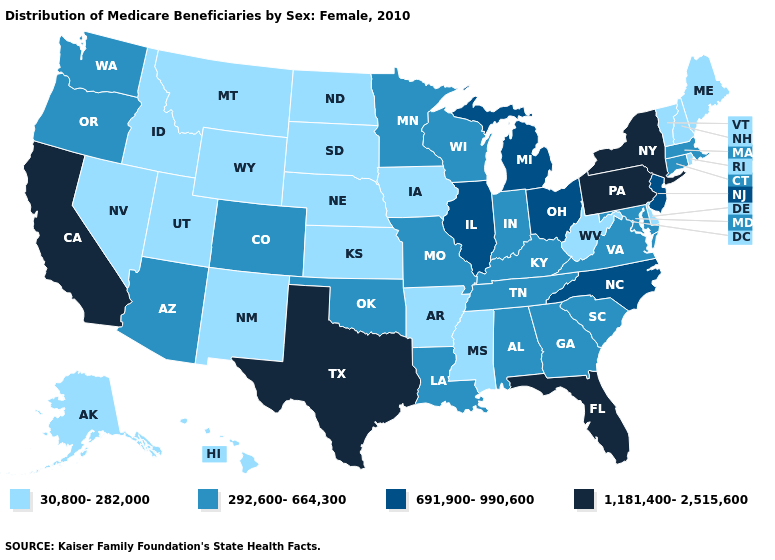Does the first symbol in the legend represent the smallest category?
Short answer required. Yes. Which states hav the highest value in the Northeast?
Answer briefly. New York, Pennsylvania. Among the states that border South Dakota , does Minnesota have the highest value?
Quick response, please. Yes. Does New Hampshire have the lowest value in the Northeast?
Answer briefly. Yes. What is the lowest value in the USA?
Short answer required. 30,800-282,000. What is the highest value in the USA?
Answer briefly. 1,181,400-2,515,600. What is the value of Virginia?
Write a very short answer. 292,600-664,300. How many symbols are there in the legend?
Give a very brief answer. 4. Does Kansas have the lowest value in the USA?
Keep it brief. Yes. Name the states that have a value in the range 691,900-990,600?
Answer briefly. Illinois, Michigan, New Jersey, North Carolina, Ohio. What is the highest value in the West ?
Concise answer only. 1,181,400-2,515,600. Which states have the highest value in the USA?
Keep it brief. California, Florida, New York, Pennsylvania, Texas. Name the states that have a value in the range 30,800-282,000?
Short answer required. Alaska, Arkansas, Delaware, Hawaii, Idaho, Iowa, Kansas, Maine, Mississippi, Montana, Nebraska, Nevada, New Hampshire, New Mexico, North Dakota, Rhode Island, South Dakota, Utah, Vermont, West Virginia, Wyoming. Which states have the lowest value in the USA?
Keep it brief. Alaska, Arkansas, Delaware, Hawaii, Idaho, Iowa, Kansas, Maine, Mississippi, Montana, Nebraska, Nevada, New Hampshire, New Mexico, North Dakota, Rhode Island, South Dakota, Utah, Vermont, West Virginia, Wyoming. What is the value of Wyoming?
Give a very brief answer. 30,800-282,000. 